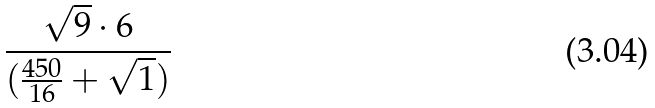<formula> <loc_0><loc_0><loc_500><loc_500>\frac { \sqrt { 9 } \cdot 6 } { ( \frac { 4 5 0 } { 1 6 } + \sqrt { 1 } ) }</formula> 